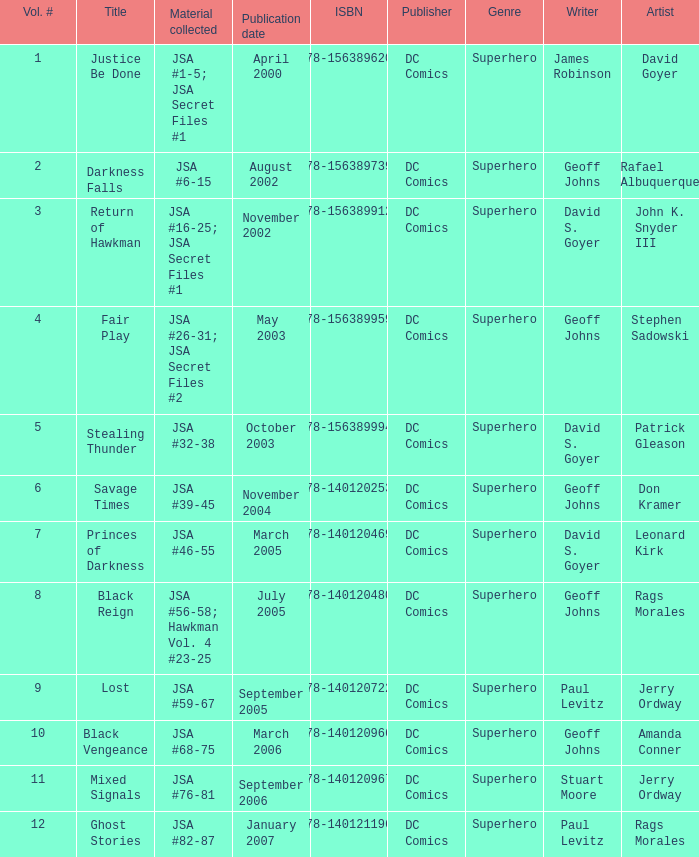Can you give me this table as a dict? {'header': ['Vol. #', 'Title', 'Material collected', 'Publication date', 'ISBN', 'Publisher', 'Genre', 'Writer', 'Artist'], 'rows': [['1', 'Justice Be Done', 'JSA #1-5; JSA Secret Files #1', 'April 2000', '978-1563896200', 'DC Comics', 'Superhero', 'James Robinson', 'David Goyer'], ['2', 'Darkness Falls', 'JSA #6-15', 'August 2002', '978-1563897399', 'DC Comics', 'Superhero', 'Geoff Johns', 'Rafael Albuquerque'], ['3', 'Return of Hawkman', 'JSA #16-25; JSA Secret Files #1', 'November 2002', '978-1563899126', 'DC Comics', 'Superhero', 'David S. Goyer', 'John K. Snyder III'], ['4', 'Fair Play', 'JSA #26-31; JSA Secret Files #2', 'May 2003', '978-1563899591', 'DC Comics', 'Superhero', 'Geoff Johns', 'Stephen Sadowski'], ['5', 'Stealing Thunder', 'JSA #32-38', 'October 2003', '978-1563899942', 'DC Comics', 'Superhero', 'David S. Goyer', 'Patrick Gleason'], ['6', 'Savage Times', 'JSA #39-45', 'November 2004', '978-1401202538', 'DC Comics', 'Superhero', 'Geoff Johns', 'Don Kramer'], ['7', 'Princes of Darkness', 'JSA #46-55', 'March 2005', '978-1401204693', 'DC Comics', 'Superhero', 'David S. Goyer', 'Leonard Kirk'], ['8', 'Black Reign', 'JSA #56-58; Hawkman Vol. 4 #23-25', 'July 2005', '978-1401204808', 'DC Comics', 'Superhero', 'Geoff Johns', 'Rags Morales'], ['9', 'Lost', 'JSA #59-67', 'September 2005', '978-1401207229', 'DC Comics', 'Superhero', 'Paul Levitz', 'Jerry Ordway'], ['10', 'Black Vengeance', 'JSA #68-75', 'March 2006', '978-1401209667', 'DC Comics', 'Superhero', 'Geoff Johns', 'Amanda Conner'], ['11', 'Mixed Signals', 'JSA #76-81', 'September 2006', '978-1401209674', 'DC Comics', 'Superhero', 'Stuart Moore', 'Jerry Ordway'], ['12', 'Ghost Stories', 'JSA #82-87', 'January 2007', '978-1401211967', 'DC Comics', 'Superhero', 'Paul Levitz', 'Rags Morales']]} What's the Material collected for the 978-1401209674 ISBN? JSA #76-81. 